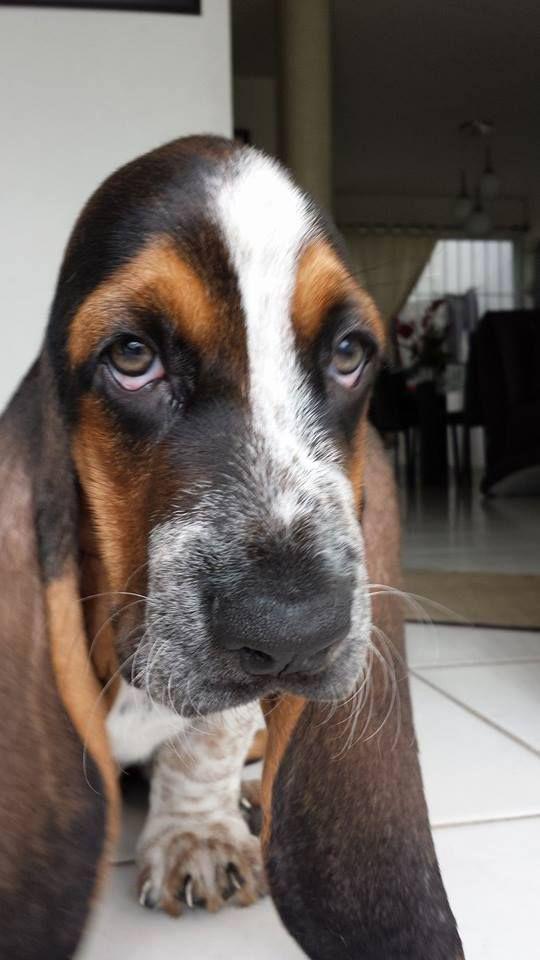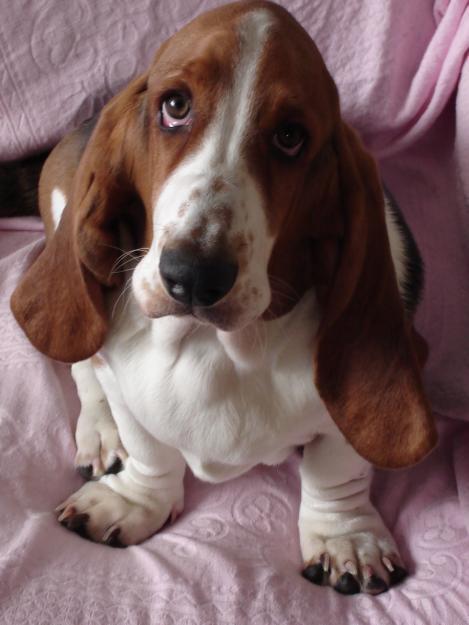The first image is the image on the left, the second image is the image on the right. For the images displayed, is the sentence "There is a Basset Hound in the image on the left." factually correct? Answer yes or no. Yes. The first image is the image on the left, the second image is the image on the right. Analyze the images presented: Is the assertion "At least one dog has long floppy brown ears, both front paws on the surface in front of it, and a body turned toward the camera." valid? Answer yes or no. Yes. 